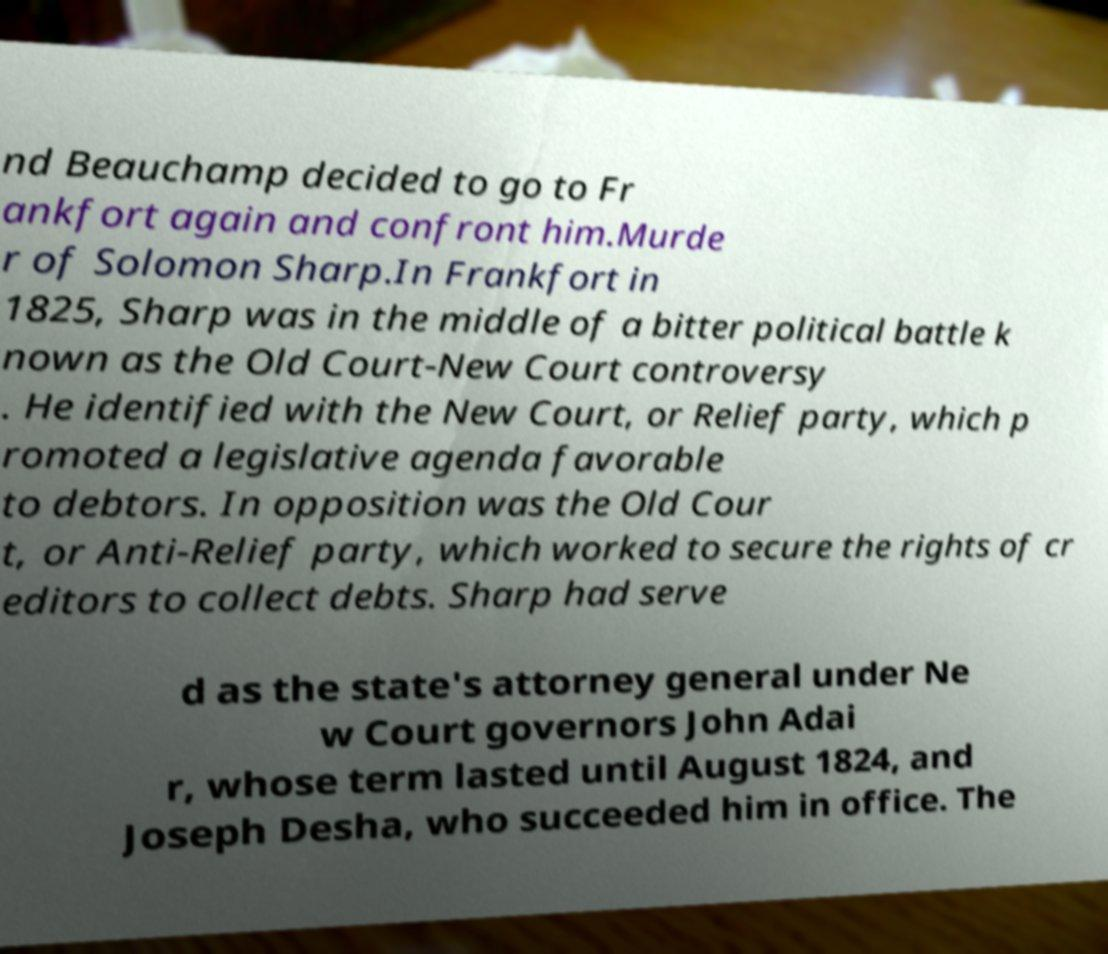What messages or text are displayed in this image? I need them in a readable, typed format. nd Beauchamp decided to go to Fr ankfort again and confront him.Murde r of Solomon Sharp.In Frankfort in 1825, Sharp was in the middle of a bitter political battle k nown as the Old Court-New Court controversy . He identified with the New Court, or Relief party, which p romoted a legislative agenda favorable to debtors. In opposition was the Old Cour t, or Anti-Relief party, which worked to secure the rights of cr editors to collect debts. Sharp had serve d as the state's attorney general under Ne w Court governors John Adai r, whose term lasted until August 1824, and Joseph Desha, who succeeded him in office. The 